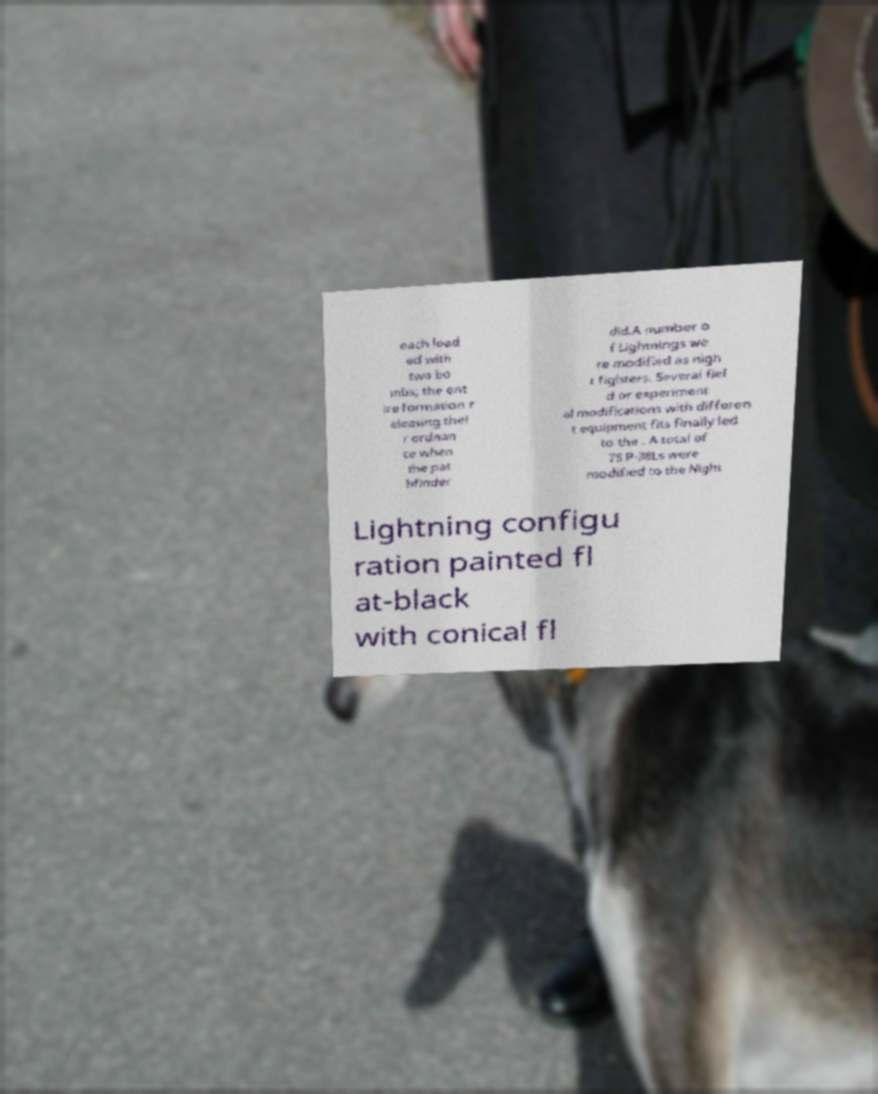What messages or text are displayed in this image? I need them in a readable, typed format. each load ed with two bo mbs; the ent ire formation r eleasing thei r ordnan ce when the pat hfinder did.A number o f Lightnings we re modified as nigh t fighters. Several fiel d or experiment al modifications with differen t equipment fits finally led to the . A total of 75 P-38Ls were modified to the Night Lightning configu ration painted fl at-black with conical fl 